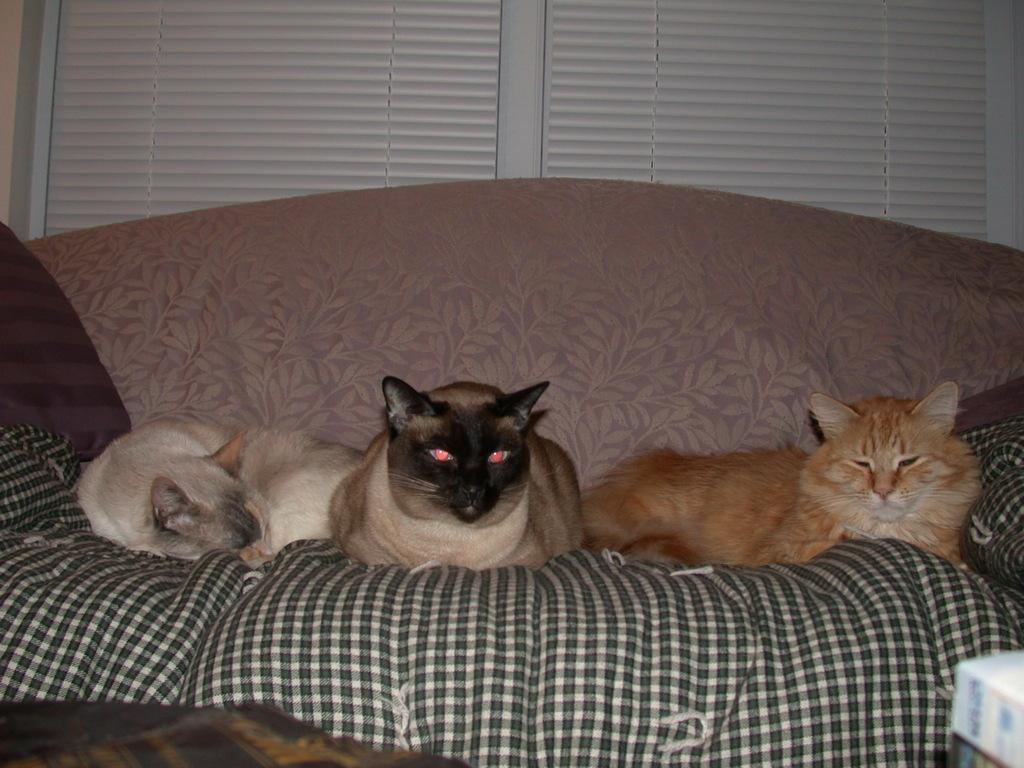What can be seen in the background of the picture? There is a window blind in the background of the picture. What type of furniture is present in the image? There are three cats on the sofa. What else can be seen at the bottom portion of the image? There are objects visible at the bottom portion of the image. What type of mint is being blown by the cats in the image? There is no mint or blowing activity present in the image; it features three cats on a sofa and a window blind in the background. 